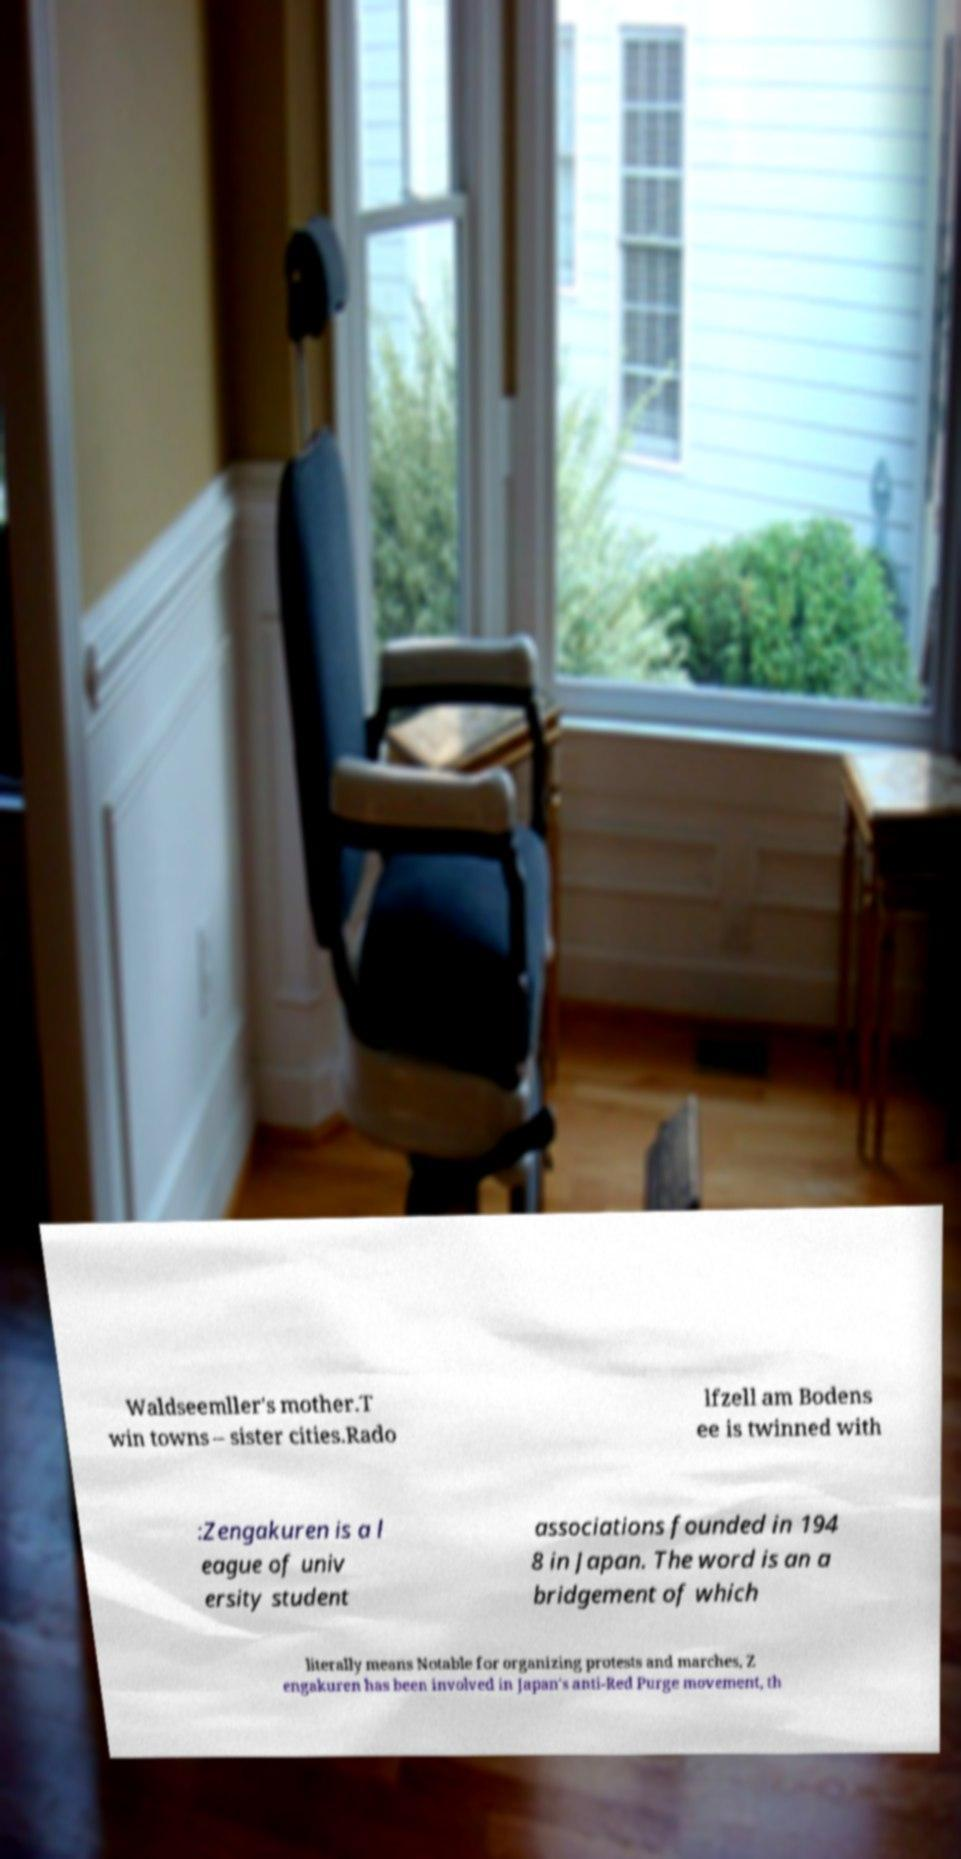For documentation purposes, I need the text within this image transcribed. Could you provide that? Waldseemller's mother.T win towns – sister cities.Rado lfzell am Bodens ee is twinned with :Zengakuren is a l eague of univ ersity student associations founded in 194 8 in Japan. The word is an a bridgement of which literally means Notable for organizing protests and marches, Z engakuren has been involved in Japan's anti-Red Purge movement, th 